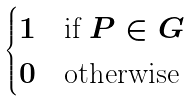<formula> <loc_0><loc_0><loc_500><loc_500>\begin{cases} 1 & \text {if $P \in G$} \\ 0 & \text {otherwise} \end{cases}</formula> 